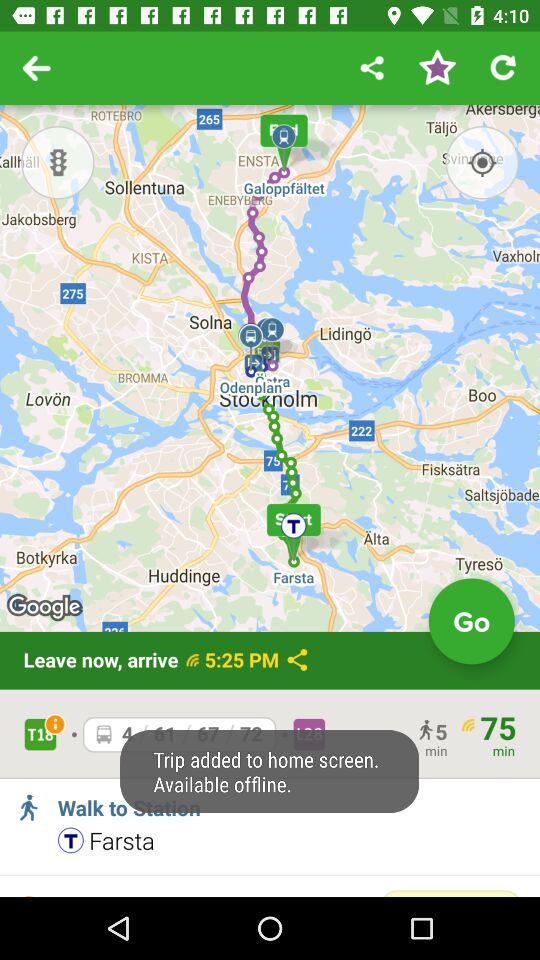How many minutes until the bus arrives at the station?
Answer the question using a single word or phrase. 75 